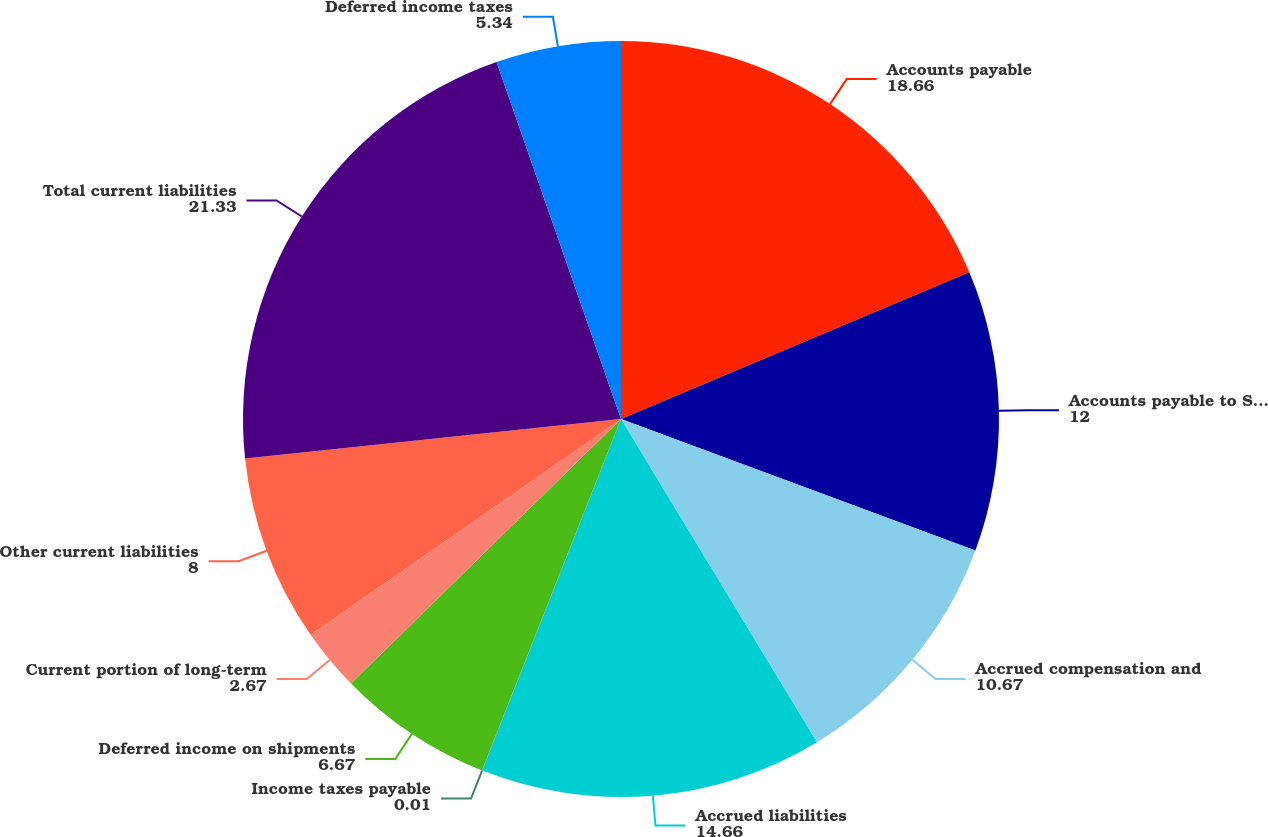Convert chart. <chart><loc_0><loc_0><loc_500><loc_500><pie_chart><fcel>Accounts payable<fcel>Accounts payable to Spansion<fcel>Accrued compensation and<fcel>Accrued liabilities<fcel>Income taxes payable<fcel>Deferred income on shipments<fcel>Current portion of long-term<fcel>Other current liabilities<fcel>Total current liabilities<fcel>Deferred income taxes<nl><fcel>18.66%<fcel>12.0%<fcel>10.67%<fcel>14.66%<fcel>0.01%<fcel>6.67%<fcel>2.67%<fcel>8.0%<fcel>21.33%<fcel>5.34%<nl></chart> 